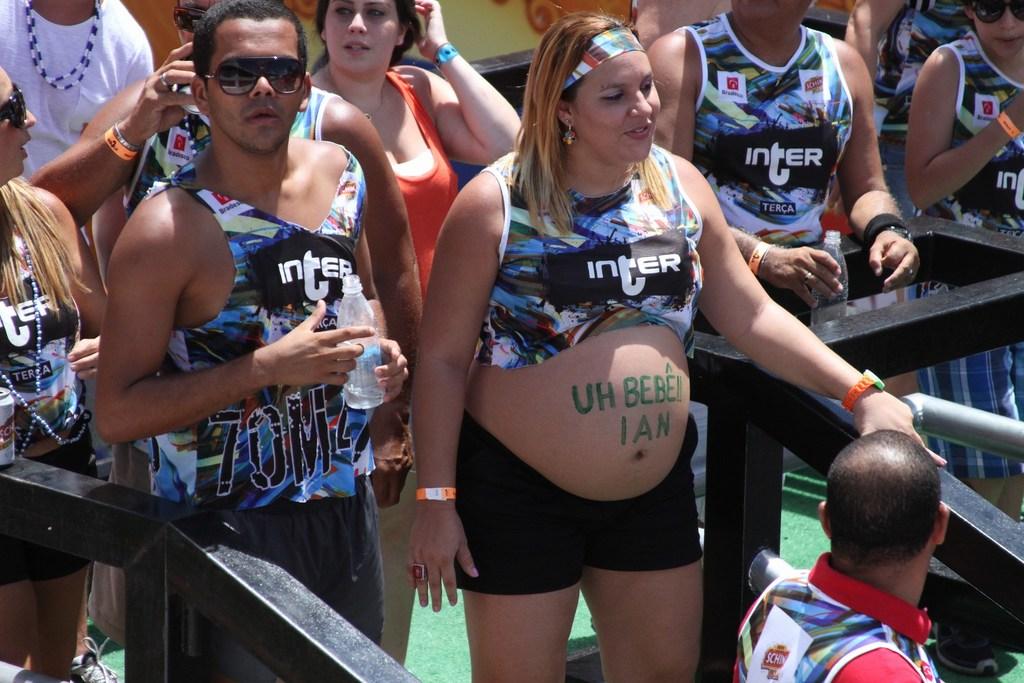What do their shirts say?
Keep it short and to the point. Inter. What does the green letters on the belly say?
Provide a succinct answer. Uh bebe! ian. 